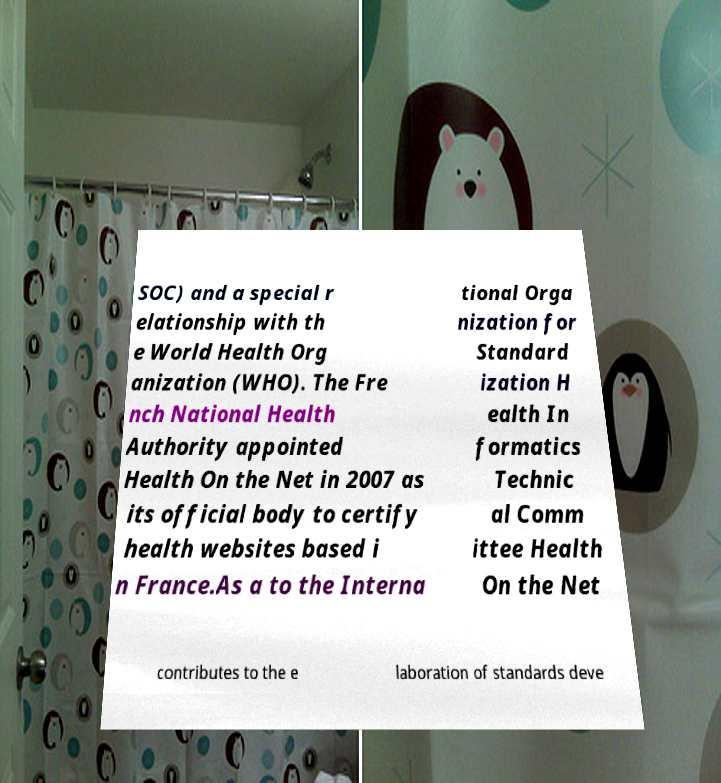Can you accurately transcribe the text from the provided image for me? SOC) and a special r elationship with th e World Health Org anization (WHO). The Fre nch National Health Authority appointed Health On the Net in 2007 as its official body to certify health websites based i n France.As a to the Interna tional Orga nization for Standard ization H ealth In formatics Technic al Comm ittee Health On the Net contributes to the e laboration of standards deve 